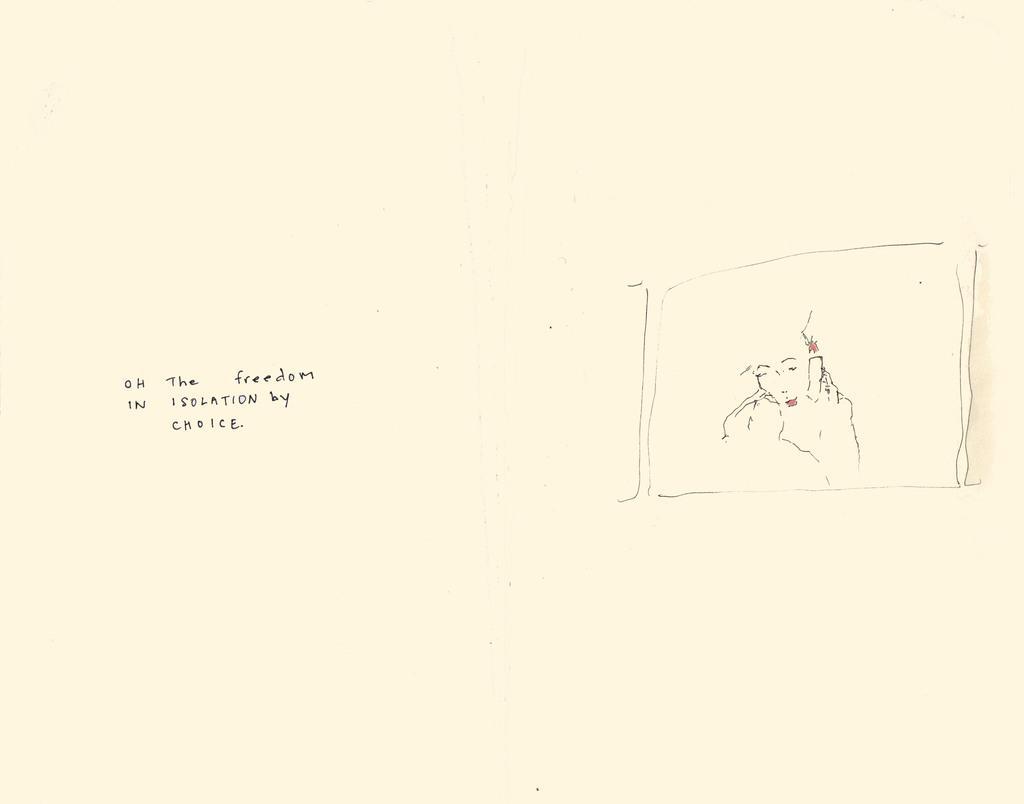Describe this image in one or two sentences. In this image there is a white surface on which there is a drawing and text written on it. 